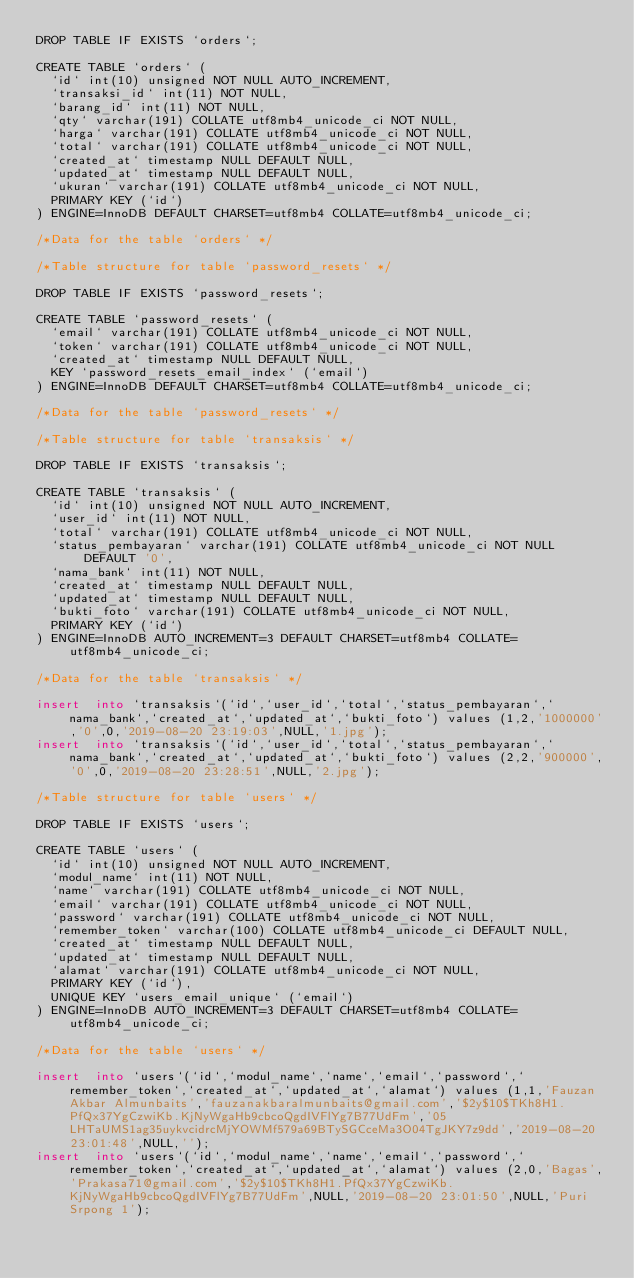Convert code to text. <code><loc_0><loc_0><loc_500><loc_500><_SQL_>DROP TABLE IF EXISTS `orders`;

CREATE TABLE `orders` (
  `id` int(10) unsigned NOT NULL AUTO_INCREMENT,
  `transaksi_id` int(11) NOT NULL,
  `barang_id` int(11) NOT NULL,
  `qty` varchar(191) COLLATE utf8mb4_unicode_ci NOT NULL,
  `harga` varchar(191) COLLATE utf8mb4_unicode_ci NOT NULL,
  `total` varchar(191) COLLATE utf8mb4_unicode_ci NOT NULL,
  `created_at` timestamp NULL DEFAULT NULL,
  `updated_at` timestamp NULL DEFAULT NULL,
  `ukuran` varchar(191) COLLATE utf8mb4_unicode_ci NOT NULL,
  PRIMARY KEY (`id`)
) ENGINE=InnoDB DEFAULT CHARSET=utf8mb4 COLLATE=utf8mb4_unicode_ci;

/*Data for the table `orders` */

/*Table structure for table `password_resets` */

DROP TABLE IF EXISTS `password_resets`;

CREATE TABLE `password_resets` (
  `email` varchar(191) COLLATE utf8mb4_unicode_ci NOT NULL,
  `token` varchar(191) COLLATE utf8mb4_unicode_ci NOT NULL,
  `created_at` timestamp NULL DEFAULT NULL,
  KEY `password_resets_email_index` (`email`)
) ENGINE=InnoDB DEFAULT CHARSET=utf8mb4 COLLATE=utf8mb4_unicode_ci;

/*Data for the table `password_resets` */

/*Table structure for table `transaksis` */

DROP TABLE IF EXISTS `transaksis`;

CREATE TABLE `transaksis` (
  `id` int(10) unsigned NOT NULL AUTO_INCREMENT,
  `user_id` int(11) NOT NULL,
  `total` varchar(191) COLLATE utf8mb4_unicode_ci NOT NULL,
  `status_pembayaran` varchar(191) COLLATE utf8mb4_unicode_ci NOT NULL DEFAULT '0',
  `nama_bank` int(11) NOT NULL,
  `created_at` timestamp NULL DEFAULT NULL,
  `updated_at` timestamp NULL DEFAULT NULL,
  `bukti_foto` varchar(191) COLLATE utf8mb4_unicode_ci NOT NULL,
  PRIMARY KEY (`id`)
) ENGINE=InnoDB AUTO_INCREMENT=3 DEFAULT CHARSET=utf8mb4 COLLATE=utf8mb4_unicode_ci;

/*Data for the table `transaksis` */

insert  into `transaksis`(`id`,`user_id`,`total`,`status_pembayaran`,`nama_bank`,`created_at`,`updated_at`,`bukti_foto`) values (1,2,'1000000','0',0,'2019-08-20 23:19:03',NULL,'1.jpg');
insert  into `transaksis`(`id`,`user_id`,`total`,`status_pembayaran`,`nama_bank`,`created_at`,`updated_at`,`bukti_foto`) values (2,2,'900000','0',0,'2019-08-20 23:28:51',NULL,'2.jpg');

/*Table structure for table `users` */

DROP TABLE IF EXISTS `users`;

CREATE TABLE `users` (
  `id` int(10) unsigned NOT NULL AUTO_INCREMENT,
  `modul_name` int(11) NOT NULL,
  `name` varchar(191) COLLATE utf8mb4_unicode_ci NOT NULL,
  `email` varchar(191) COLLATE utf8mb4_unicode_ci NOT NULL,
  `password` varchar(191) COLLATE utf8mb4_unicode_ci NOT NULL,
  `remember_token` varchar(100) COLLATE utf8mb4_unicode_ci DEFAULT NULL,
  `created_at` timestamp NULL DEFAULT NULL,
  `updated_at` timestamp NULL DEFAULT NULL,
  `alamat` varchar(191) COLLATE utf8mb4_unicode_ci NOT NULL,
  PRIMARY KEY (`id`),
  UNIQUE KEY `users_email_unique` (`email`)
) ENGINE=InnoDB AUTO_INCREMENT=3 DEFAULT CHARSET=utf8mb4 COLLATE=utf8mb4_unicode_ci;

/*Data for the table `users` */

insert  into `users`(`id`,`modul_name`,`name`,`email`,`password`,`remember_token`,`created_at`,`updated_at`,`alamat`) values (1,1,'Fauzan Akbar Almunbaits','fauzanakbaralmunbaits@gmail.com','$2y$10$TKh8H1.PfQx37YgCzwiKb.KjNyWgaHb9cbcoQgdIVFlYg7B77UdFm','05LHTaUMS1ag35uykvcidrcMjYOWMf579a69BTySGCceMa3O04TgJKY7z9dd','2019-08-20 23:01:48',NULL,'');
insert  into `users`(`id`,`modul_name`,`name`,`email`,`password`,`remember_token`,`created_at`,`updated_at`,`alamat`) values (2,0,'Bagas','Prakasa71@gmail.com','$2y$10$TKh8H1.PfQx37YgCzwiKb.KjNyWgaHb9cbcoQgdIVFlYg7B77UdFm',NULL,'2019-08-20 23:01:50',NULL,'Puri Srpong 1');
</code> 